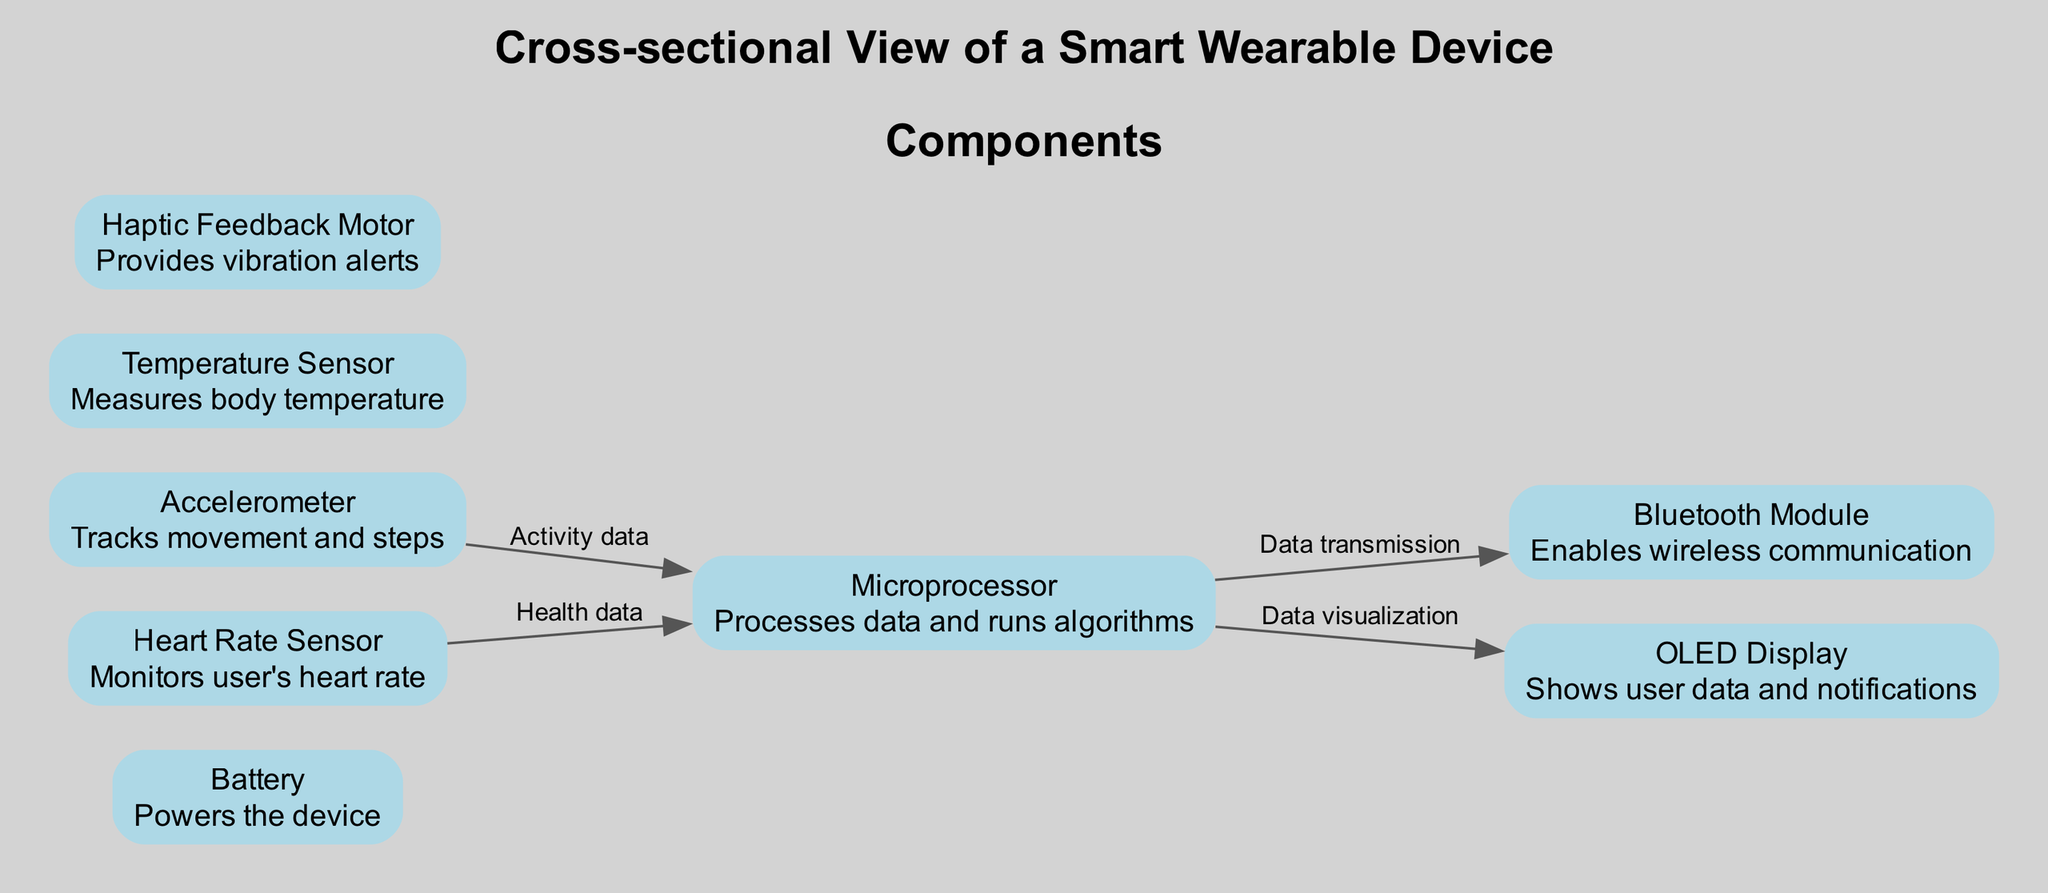What component displays user notifications? The diagram shows that the "OLED Display" component is responsible for displaying user data and notifications. This is directly stated in the description of the OLED Display.
Answer: OLED Display How many sensors are present in the device? According to the diagram, there are three sensors: the Heart Rate Sensor, Accelerometer, and Temperature Sensor. This can be counted directly from the components list.
Answer: 3 What does the Microprocessor connect to for data transmission? From the diagram, the Microprocessor connects to the Bluetooth Module for data transmission. This connection is specifically labeled as "Data transmission" in the diagram.
Answer: Bluetooth Module Which component monitors the user's heart rate? The diagram identifies the "Heart Rate Sensor" as the component that monitors the user's heart rate, as explicitly mentioned in its description.
Answer: Heart Rate Sensor What is the main function of the Battery? The diagram states that the Battery powers the device, indicating its primary function. This is outlined clearly in the description of the Battery.
Answer: Powers the device Which component provides vibration alerts? According to the diagram, the "Haptic Feedback Motor" is the component that provides vibration alerts, as indicated in its description.
Answer: Haptic Feedback Motor What type of data does the Accelerometer send to the Microprocessor? The diagram specifies that the Accelerometer sends "Activity data" to the Microprocessor, labeled as such in the connection details. This indicates the type of information transmitted.
Answer: Activity data Where does the Heart Rate Sensor send health data? The diagram shows that the Heart Rate Sensor sends health data to the Microprocessor, which is clearly indicated by the labeled connection between these two components.
Answer: Microprocessor Which component enables wireless communication? The "Bluetooth Module" is identified in the diagram as the component that enables wireless communication, as stated in its description.
Answer: Bluetooth Module 